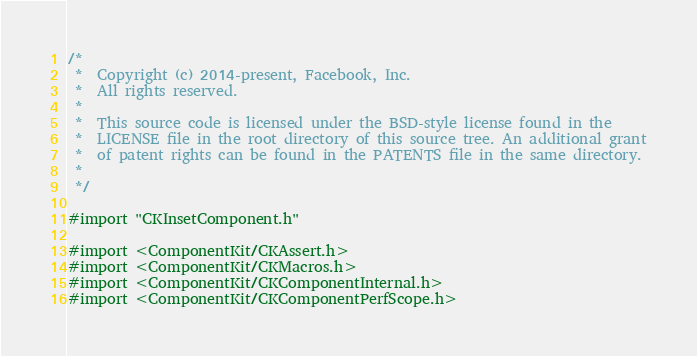<code> <loc_0><loc_0><loc_500><loc_500><_ObjectiveC_>/*
 *  Copyright (c) 2014-present, Facebook, Inc.
 *  All rights reserved.
 *
 *  This source code is licensed under the BSD-style license found in the
 *  LICENSE file in the root directory of this source tree. An additional grant
 *  of patent rights can be found in the PATENTS file in the same directory.
 *
 */

#import "CKInsetComponent.h"

#import <ComponentKit/CKAssert.h>
#import <ComponentKit/CKMacros.h>
#import <ComponentKit/CKComponentInternal.h>
#import <ComponentKit/CKComponentPerfScope.h></code> 